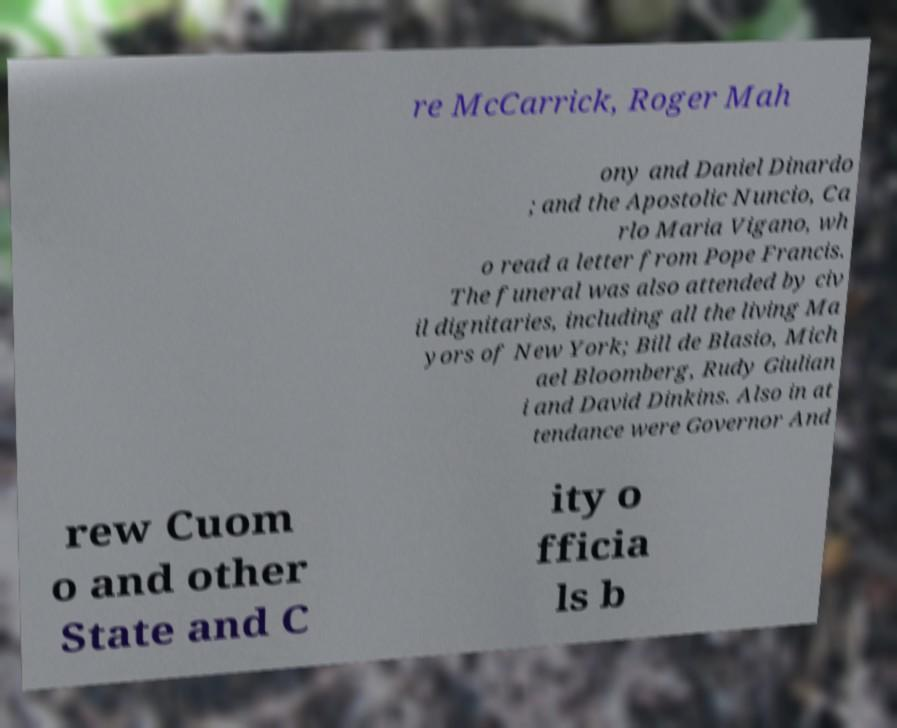Could you extract and type out the text from this image? re McCarrick, Roger Mah ony and Daniel Dinardo ; and the Apostolic Nuncio, Ca rlo Maria Vigano, wh o read a letter from Pope Francis. The funeral was also attended by civ il dignitaries, including all the living Ma yors of New York; Bill de Blasio, Mich ael Bloomberg, Rudy Giulian i and David Dinkins. Also in at tendance were Governor And rew Cuom o and other State and C ity o fficia ls b 